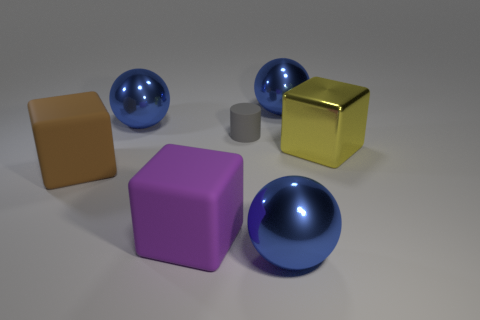Subtract all blue balls. How many were subtracted if there are1blue balls left? 2 Subtract all purple cubes. How many cubes are left? 2 Subtract 3 balls. How many balls are left? 0 Subtract all yellow cubes. How many cubes are left? 2 Add 2 purple things. How many objects exist? 9 Subtract all green cylinders. Subtract all cyan blocks. How many cylinders are left? 1 Subtract all blocks. How many objects are left? 4 Subtract all yellow cylinders. How many gray cubes are left? 0 Subtract all yellow blocks. Subtract all big yellow cubes. How many objects are left? 5 Add 1 large yellow metal cubes. How many large yellow metal cubes are left? 2 